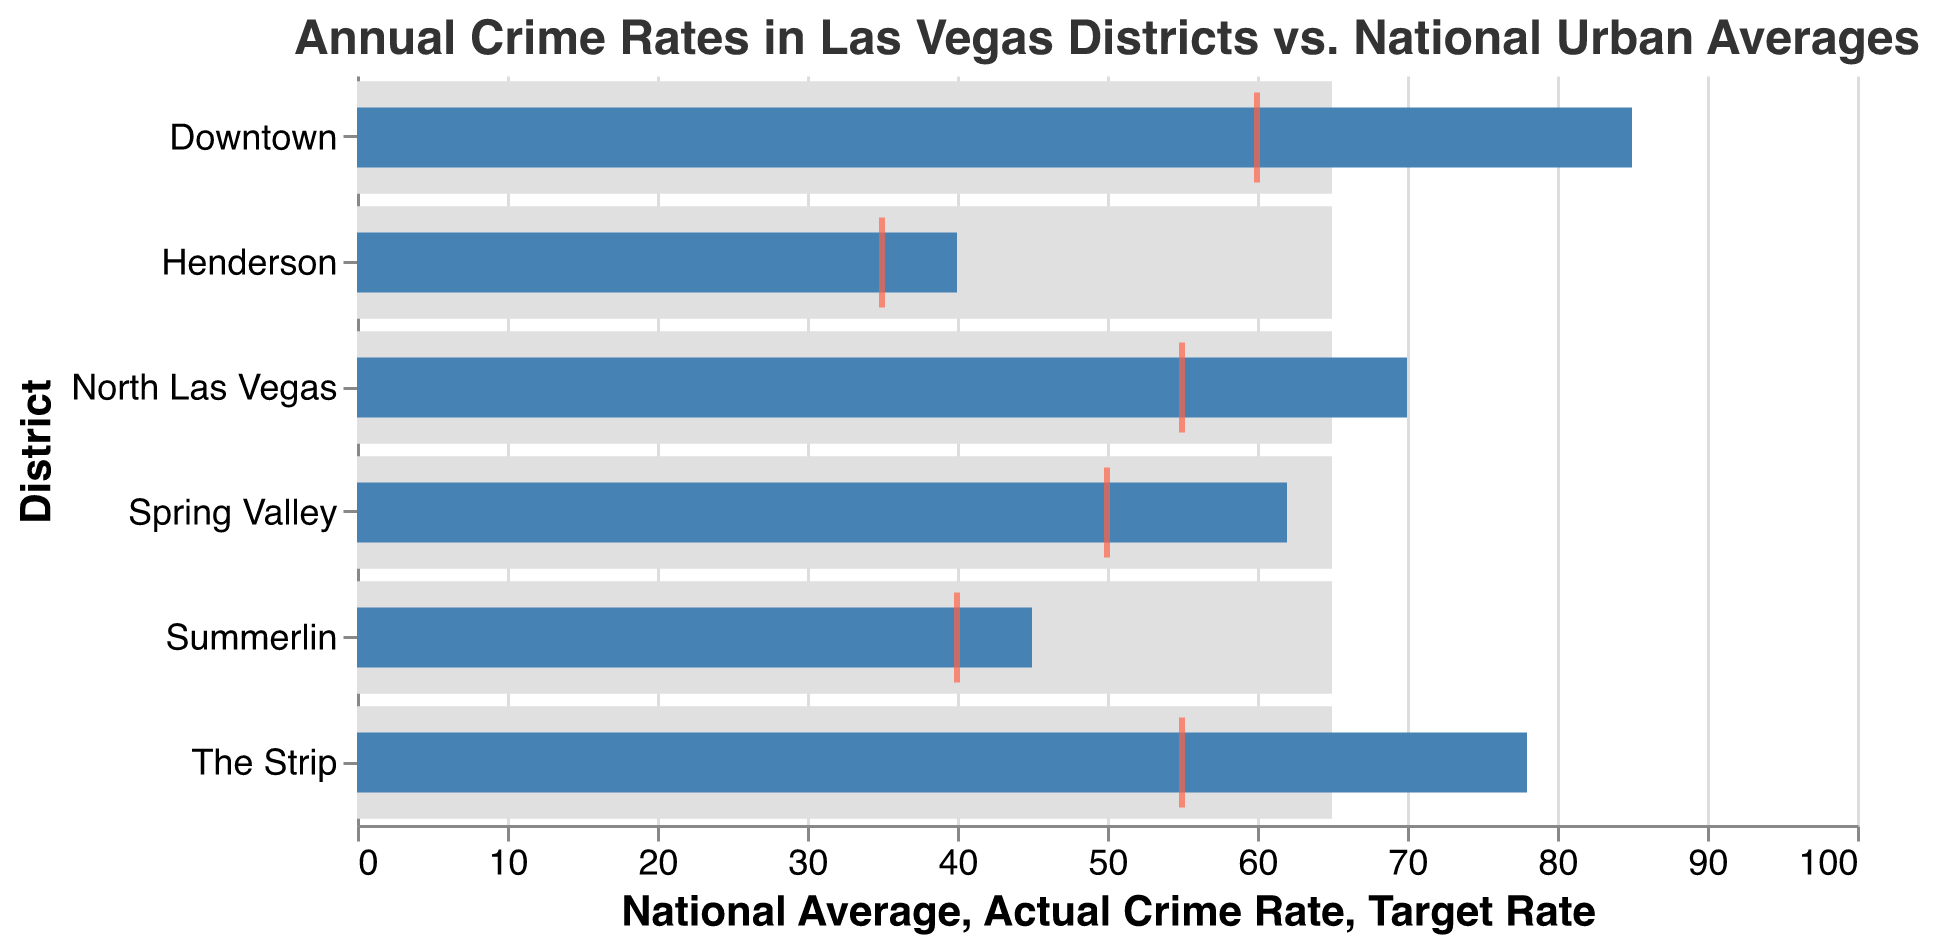What's the title of the chart? The title of the chart is displayed at the top of the visual and reads "Annual Crime Rates in Las Vegas Districts vs. National Urban Averages."
Answer: Annual Crime Rates in Las Vegas Districts vs. National Urban Averages How many districts are included in the chart? By looking at the y-axis labels, we can count six district names listed: Downtown, The Strip, Summerlin, Spring Valley, North Las Vegas, and Henderson.
Answer: Six Which district has the highest actual crime rate, and what is it? The longest blue bar represents the highest actual crime rate. It belongs to the "Downtown" district with an actual crime rate of 85, as labeled at the end of the bar.
Answer: Downtown, 85 Which district has the actual crime rate closest to the national average? We look for the blue bar (actual crime rate) closest to the grey bar (national average). "Spring Valley" has an actual crime rate of 62, closest to the national average of 65.
Answer: Spring Valley What is the difference between the actual crime rate and the target rate for The Strip? Subtract the target rate (55) from the actual crime rate (78) to find the difference: 78 - 55 = 23.
Answer: 23 How does Henderson's actual crime rate compare to its target rate? The tick mark (target rate) for Henderson is at 35, and its actual crime rate bar is at 40. The actual rate is 5 units higher than the target rate: 40 - 35 = 5.
Answer: 5 units higher Which district has the lowest actual crime rate, and what is it? The shortest blue bar represents the lowest actual crime rate. It belongs to the "Henderson" district with an actual crime rate of 40, as indicated at the end of the bar.
Answer: Henderson, 40 Which two districts have an actual crime rate exceeding the national average by 10 or more units? Compare actual crime rates to the national average (65). "Downtown" with 85 (85 - 65 = 20) and "The Strip" with 78 (78 - 65 = 13) exceed by 10 or more units.
Answer: Downtown, The Strip What is the average of the actual crime rates for all districts? Sum all actual crime rates: 85 + 78 + 45 + 62 + 70 + 40 = 380. Divide by the number of districts: 380 / 6 = 63.3.
Answer: 63.3 Which districts have an actual crime rate below the national average? Identify districts where the blue bar is shorter than the grey bar. Districts: Summerlin (45), Spring Valley (62), Henderson (40).
Answer: Summerlin, Spring Valley, Henderson 